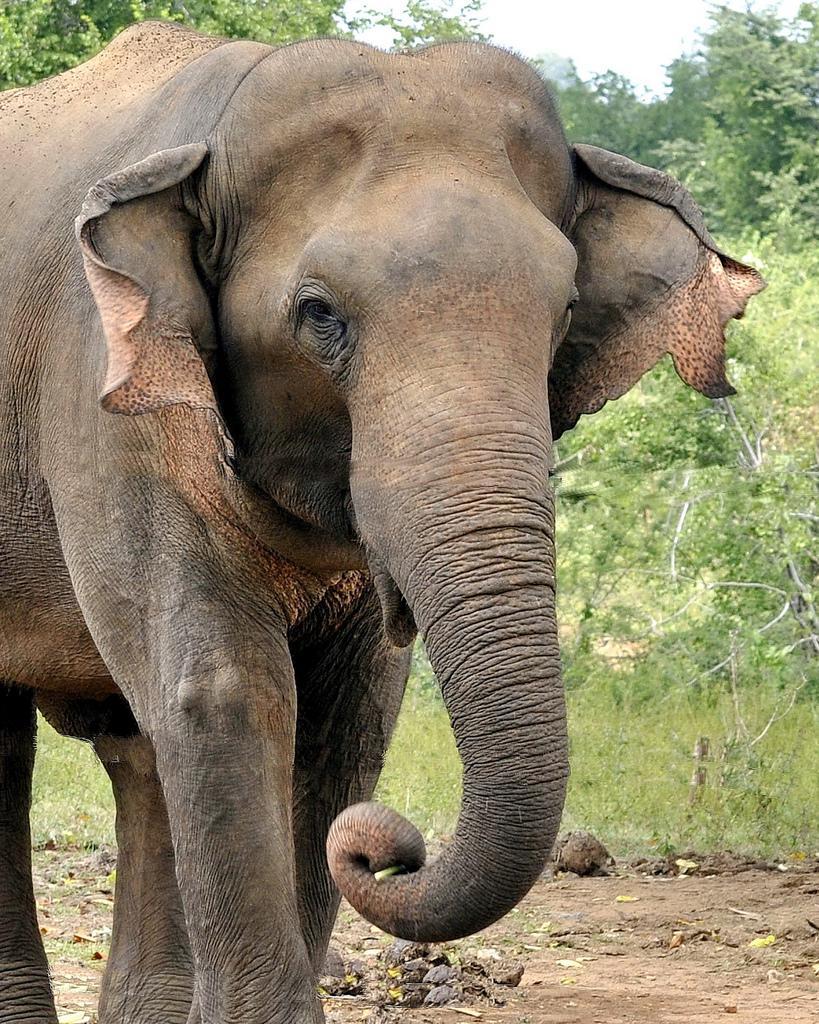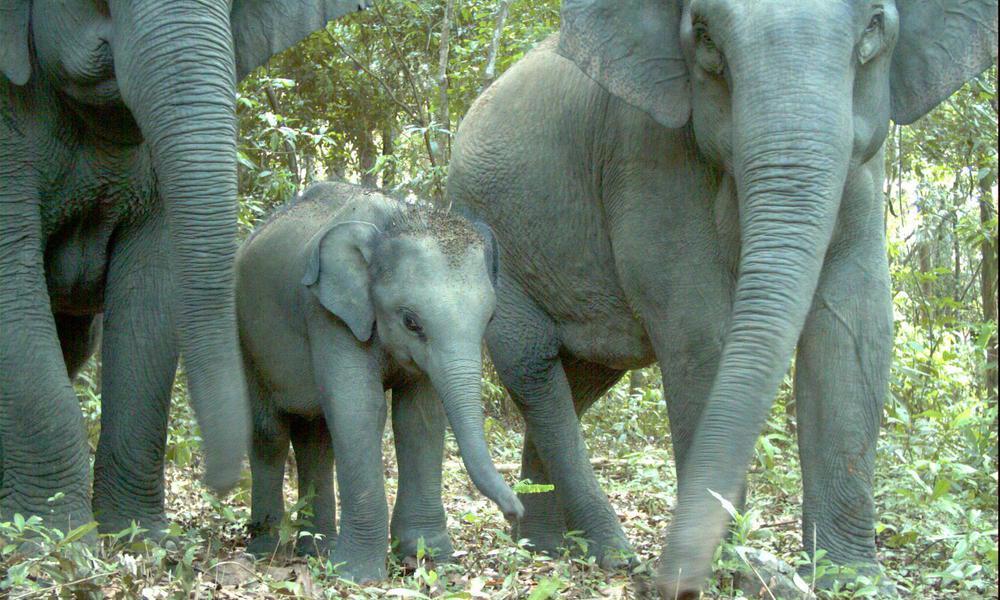The first image is the image on the left, the second image is the image on the right. Assess this claim about the two images: "Both elephants have white tusks.". Correct or not? Answer yes or no. No. 